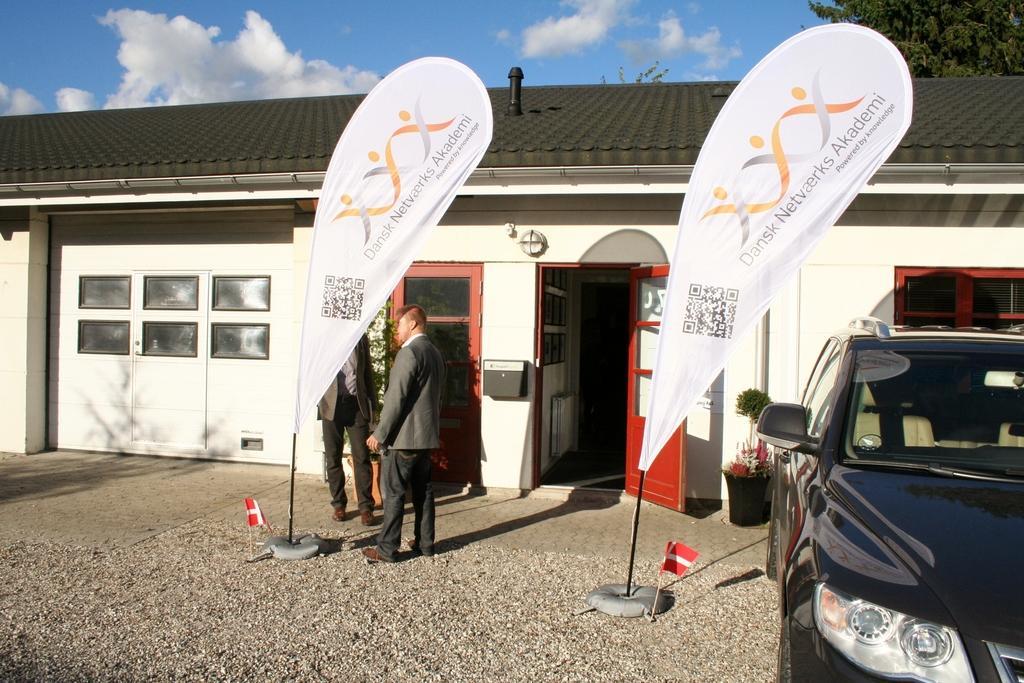How would you summarize this image in a sentence or two? In this image there are two persons standing, on either side of the persons there are flags and a car is parked near to the flag in the background there is a house to that house there are windows and doors, in the background there is tree and blue sky. 